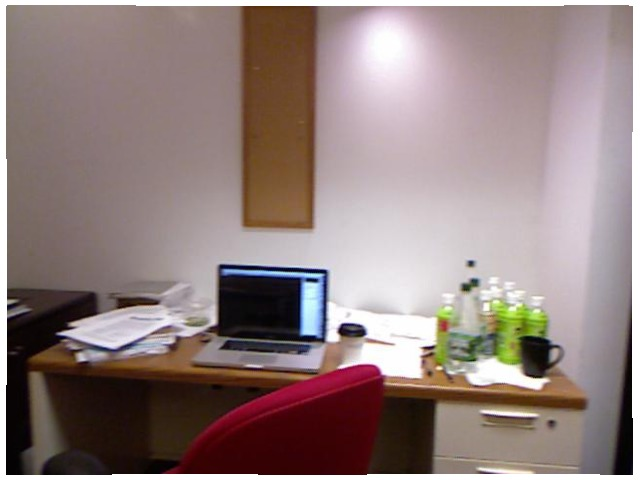<image>
Is there a laptop on the table? Yes. Looking at the image, I can see the laptop is positioned on top of the table, with the table providing support. Where is the chair in relation to the table? Is it on the table? No. The chair is not positioned on the table. They may be near each other, but the chair is not supported by or resting on top of the table. Where is the laptop in relation to the chair? Is it next to the chair? Yes. The laptop is positioned adjacent to the chair, located nearby in the same general area. Is there a wall behind the laptop? Yes. From this viewpoint, the wall is positioned behind the laptop, with the laptop partially or fully occluding the wall. Is there a laptop in the bottle? No. The laptop is not contained within the bottle. These objects have a different spatial relationship. 